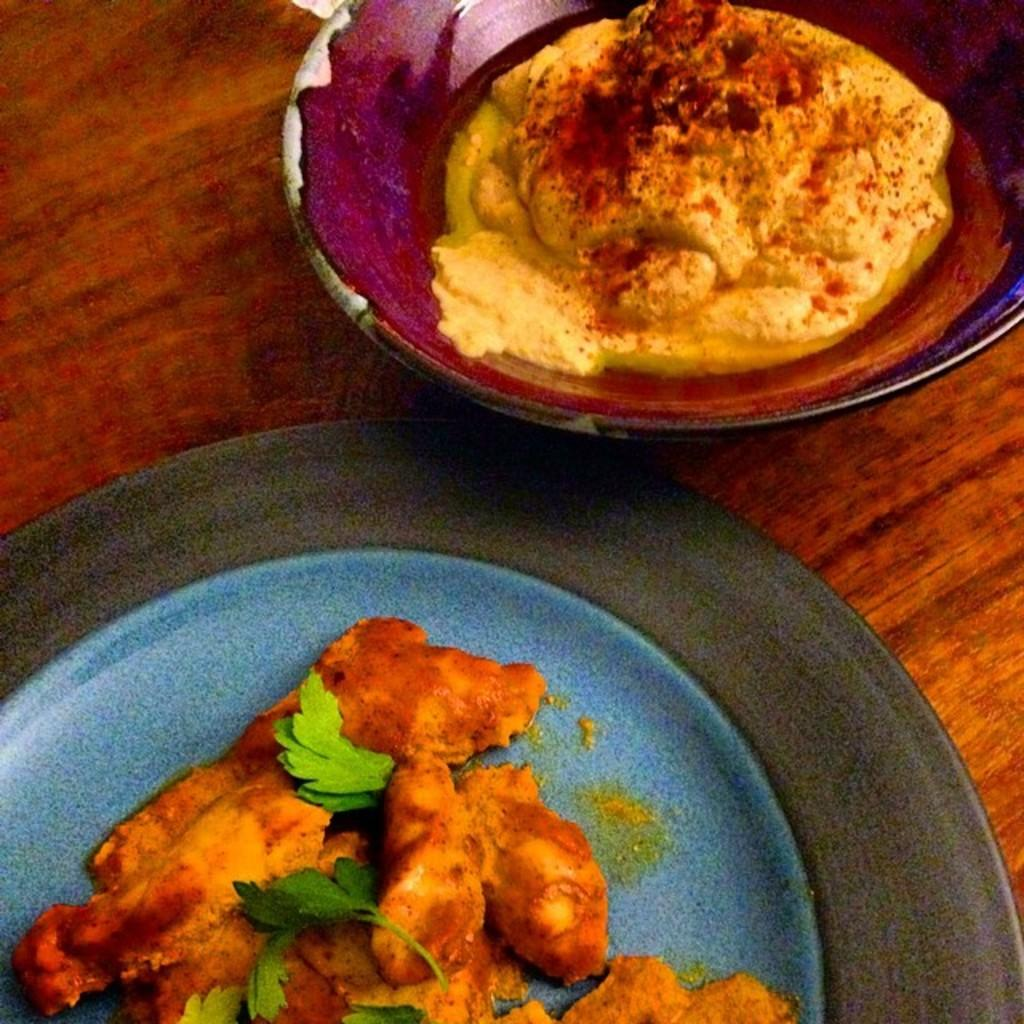What type of food items can be seen on a plate in the image? There are food items on a plate in the image. What type of food items can be seen in a bowl in the image? There are food items in a bowl in the image. Where are the food items located in the image? The food items are on a plate and in a bowl, and there is a table at the bottom of the image. What type of muscle is visible in the image? There is no muscle visible in the image; it features food items on a plate and in a bowl. What type of government is depicted in the image? There is no government depicted in the image; it features food items on a plate and in a bowl. 